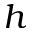Convert formula to latex. <formula><loc_0><loc_0><loc_500><loc_500>h</formula> 